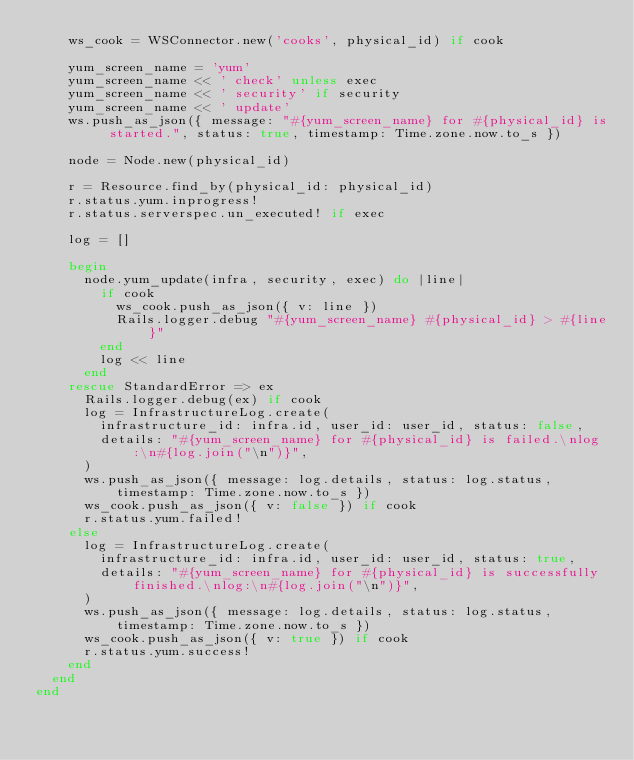Convert code to text. <code><loc_0><loc_0><loc_500><loc_500><_Ruby_>    ws_cook = WSConnector.new('cooks', physical_id) if cook

    yum_screen_name = 'yum'
    yum_screen_name << ' check' unless exec
    yum_screen_name << ' security' if security
    yum_screen_name << ' update'
    ws.push_as_json({ message: "#{yum_screen_name} for #{physical_id} is started.", status: true, timestamp: Time.zone.now.to_s })

    node = Node.new(physical_id)

    r = Resource.find_by(physical_id: physical_id)
    r.status.yum.inprogress!
    r.status.serverspec.un_executed! if exec

    log = []

    begin
      node.yum_update(infra, security, exec) do |line|
        if cook
          ws_cook.push_as_json({ v: line })
          Rails.logger.debug "#{yum_screen_name} #{physical_id} > #{line}"
        end
        log << line
      end
    rescue StandardError => ex
      Rails.logger.debug(ex) if cook
      log = InfrastructureLog.create(
        infrastructure_id: infra.id, user_id: user_id, status: false,
        details: "#{yum_screen_name} for #{physical_id} is failed.\nlog:\n#{log.join("\n")}",
      )
      ws.push_as_json({ message: log.details, status: log.status, timestamp: Time.zone.now.to_s })
      ws_cook.push_as_json({ v: false }) if cook
      r.status.yum.failed!
    else
      log = InfrastructureLog.create(
        infrastructure_id: infra.id, user_id: user_id, status: true,
        details: "#{yum_screen_name} for #{physical_id} is successfully finished.\nlog:\n#{log.join("\n")}",
      )
      ws.push_as_json({ message: log.details, status: log.status, timestamp: Time.zone.now.to_s })
      ws_cook.push_as_json({ v: true }) if cook
      r.status.yum.success!
    end
  end
end
</code> 